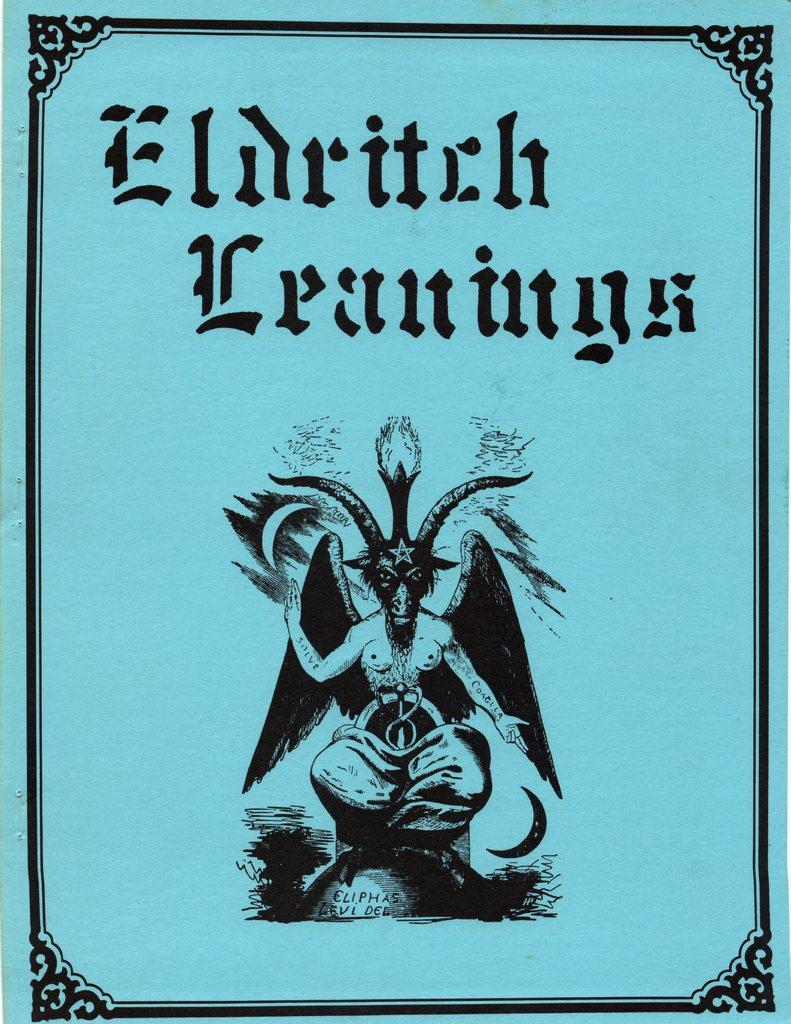<image>
Present a compact description of the photo's key features. Cover of a book showing a creature named, "Eldritch Eranings." 